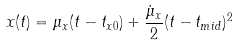Convert formula to latex. <formula><loc_0><loc_0><loc_500><loc_500>x ( t ) = \mu _ { x } ( t - t _ { x 0 } ) + \frac { \dot { \mu } _ { x } } { 2 } ( t - t _ { m i d } ) ^ { 2 }</formula> 